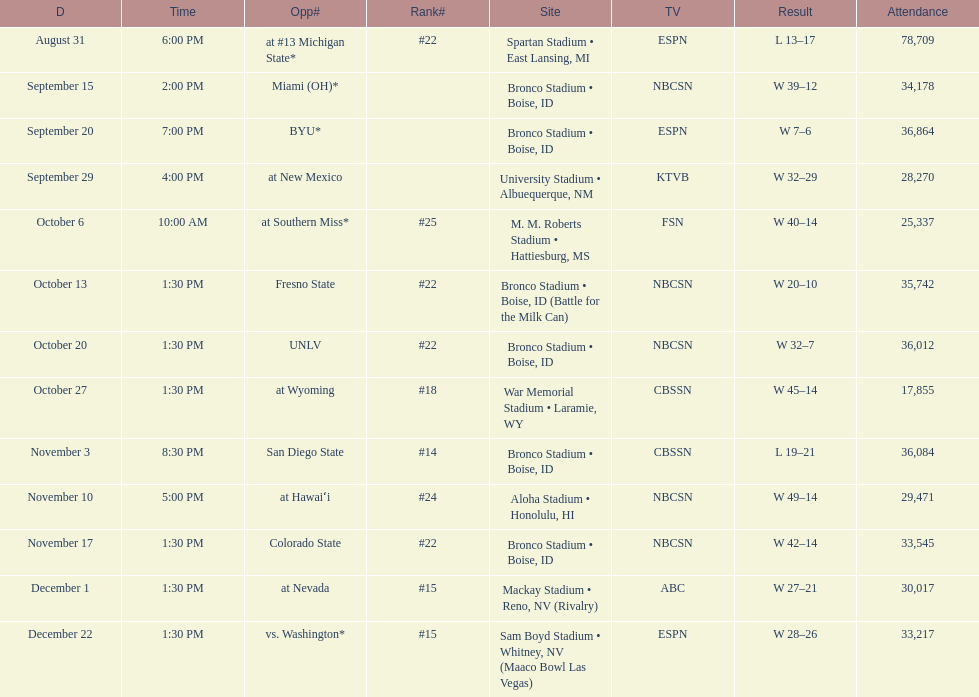What is the score difference for the game against michigan state? 4. 